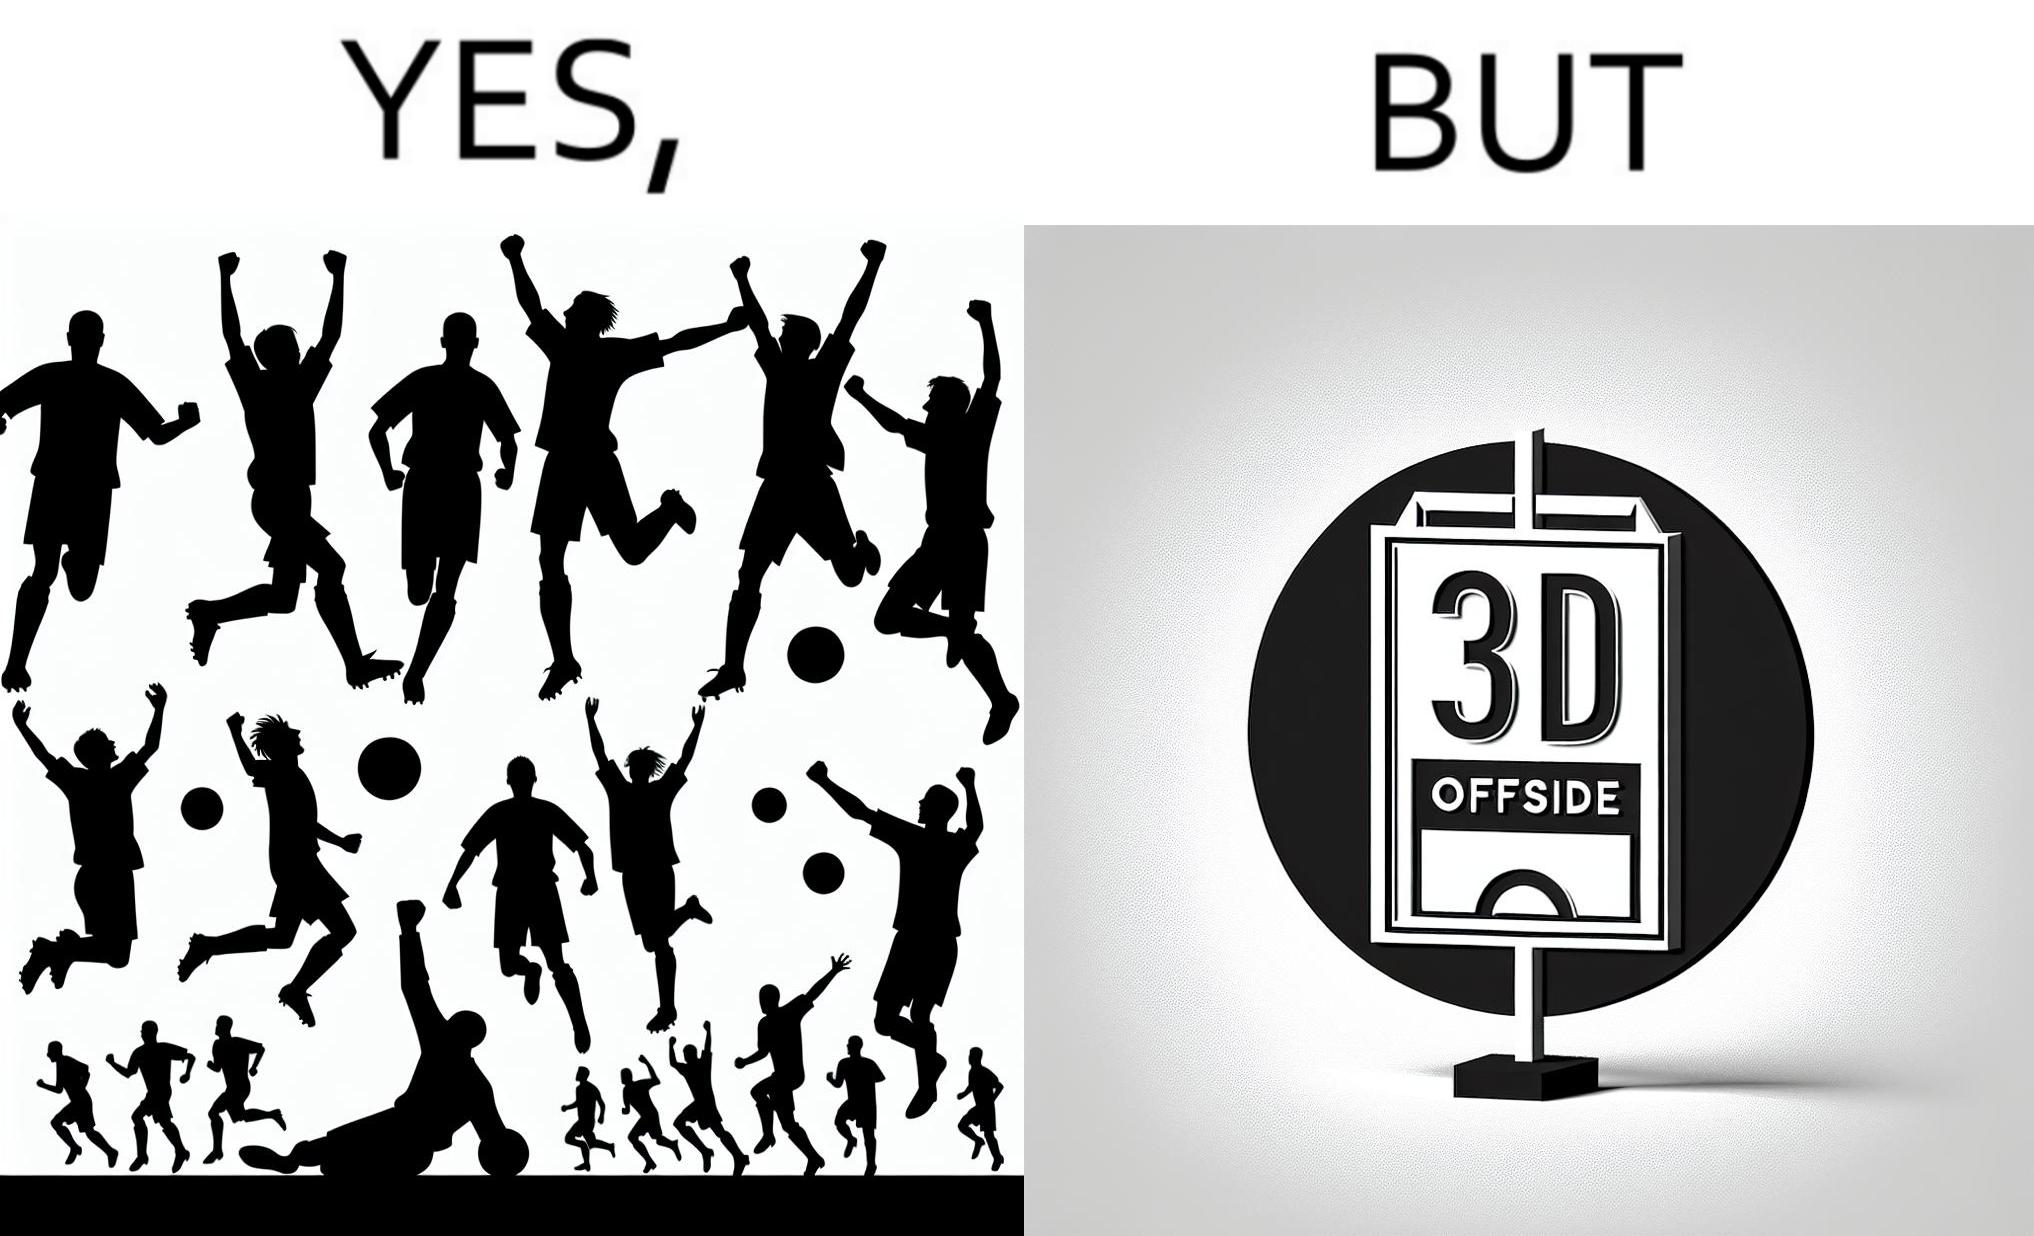Provide a description of this image. The image is ironical, as the team is celebrating as they think that they have scored a goal, but the sign on the screen says that it is an offside, and not a goal. This is a very common scenario in football matches. 